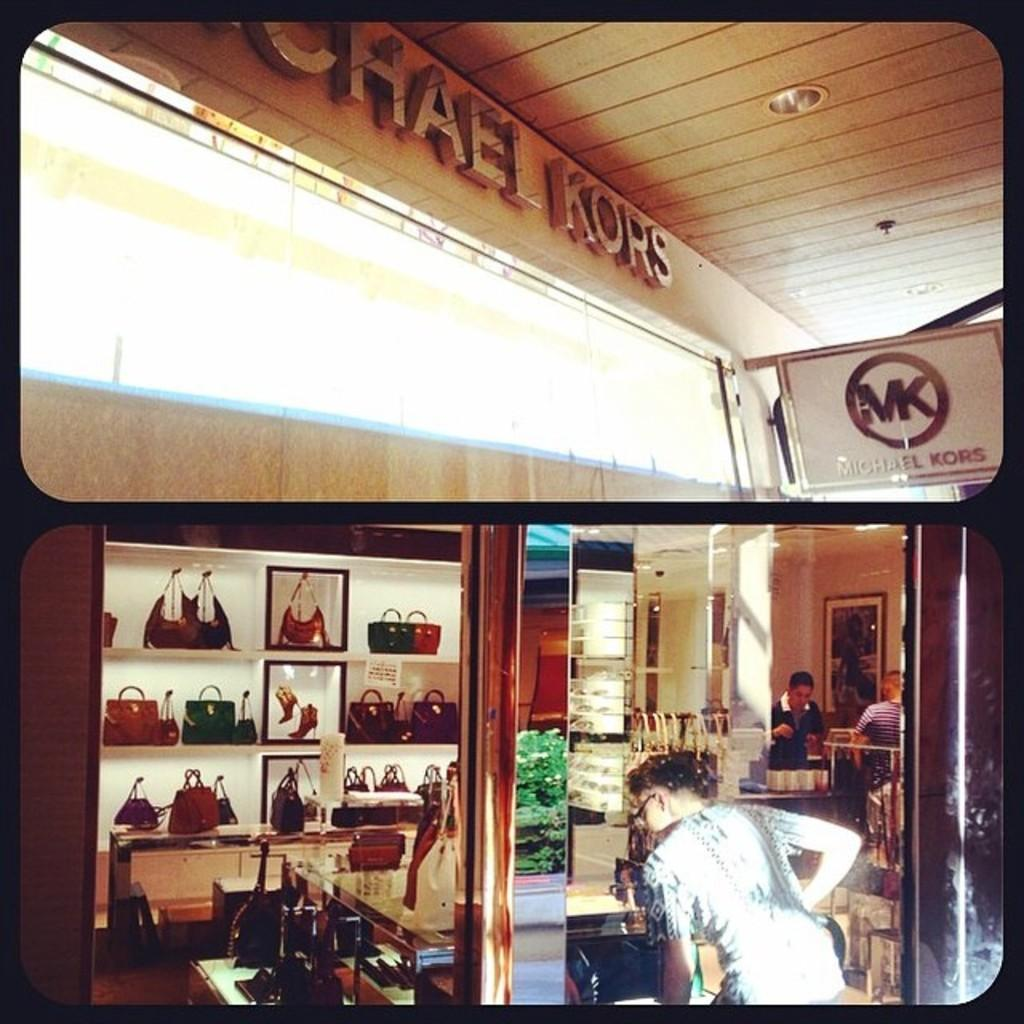Where is the woman located in the image? The woman is standing on the right side in the back of the image. What can be seen on the shelves in the image? The shelves contain handbags. What type of store might this be based on the items on the shelves? The setting appears to be in a bag store. What color of paint is being used on the toy in the image? There is no toy or paint present in the image. 